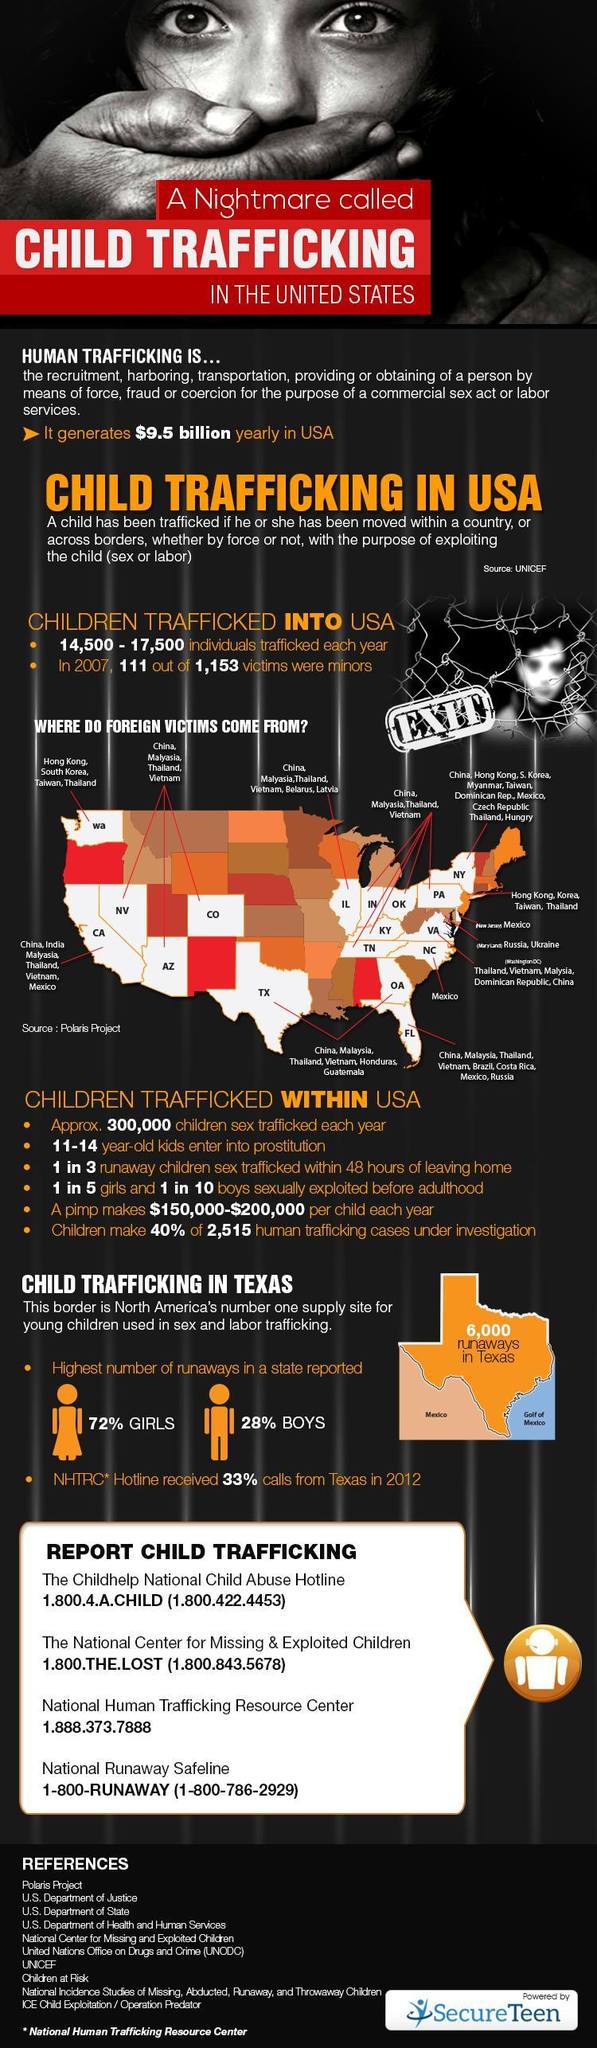How many helpline numbers are given?
Answer the question with a short phrase. 4 Which state had the most cases reported in 2012? Texas 